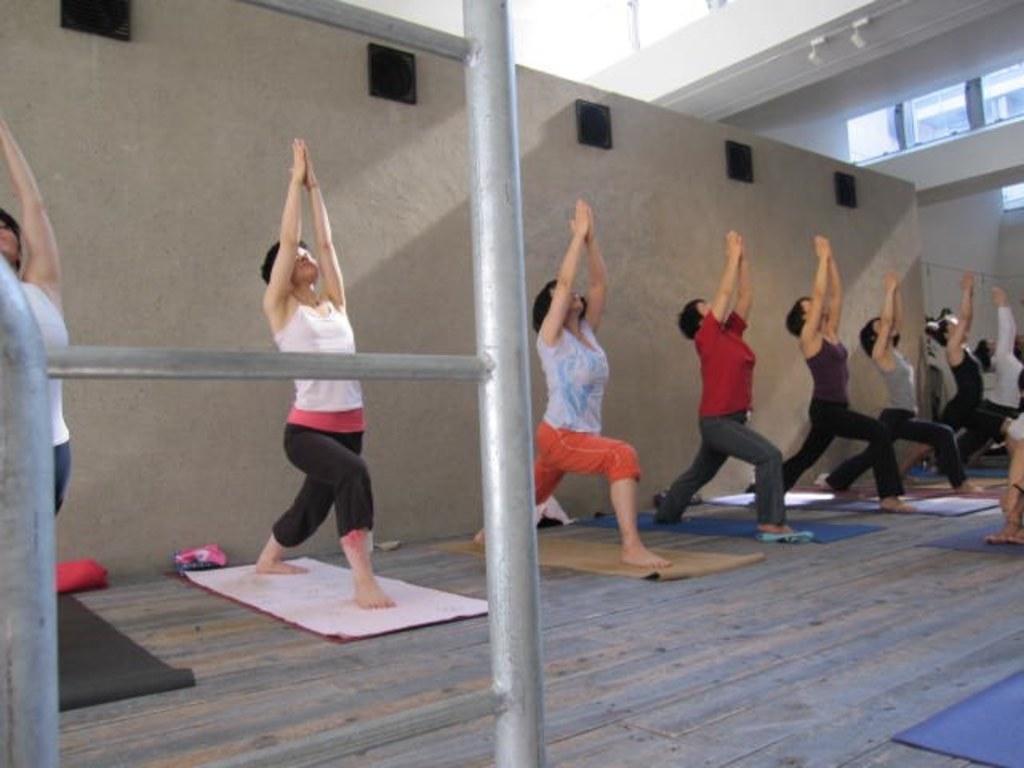In one or two sentences, can you explain what this image depicts? In this picture, we can see a few people doing yoga, we can see the ground and some objects on the ground like mats, poles, and we can see the wall and some objects attached to it like, windows, glass doors. 